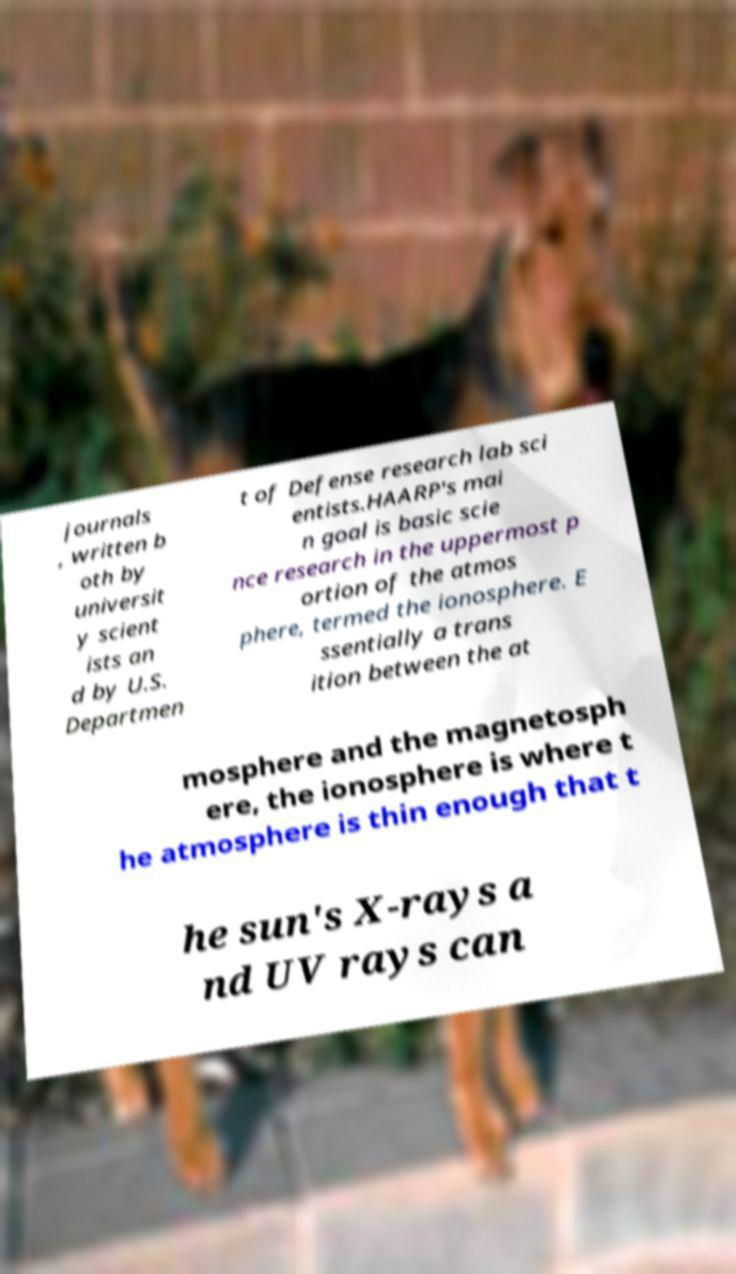Could you assist in decoding the text presented in this image and type it out clearly? journals , written b oth by universit y scient ists an d by U.S. Departmen t of Defense research lab sci entists.HAARP's mai n goal is basic scie nce research in the uppermost p ortion of the atmos phere, termed the ionosphere. E ssentially a trans ition between the at mosphere and the magnetosph ere, the ionosphere is where t he atmosphere is thin enough that t he sun's X-rays a nd UV rays can 